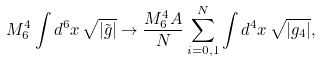<formula> <loc_0><loc_0><loc_500><loc_500>M _ { 6 } ^ { 4 } \int d ^ { 6 } x \, \sqrt { | \tilde { g } | } \rightarrow \frac { M _ { 6 } ^ { 4 } A } { N } \sum _ { i = 0 , 1 } ^ { N } \int d ^ { 4 } x \, \sqrt { | g _ { 4 } | } ,</formula> 